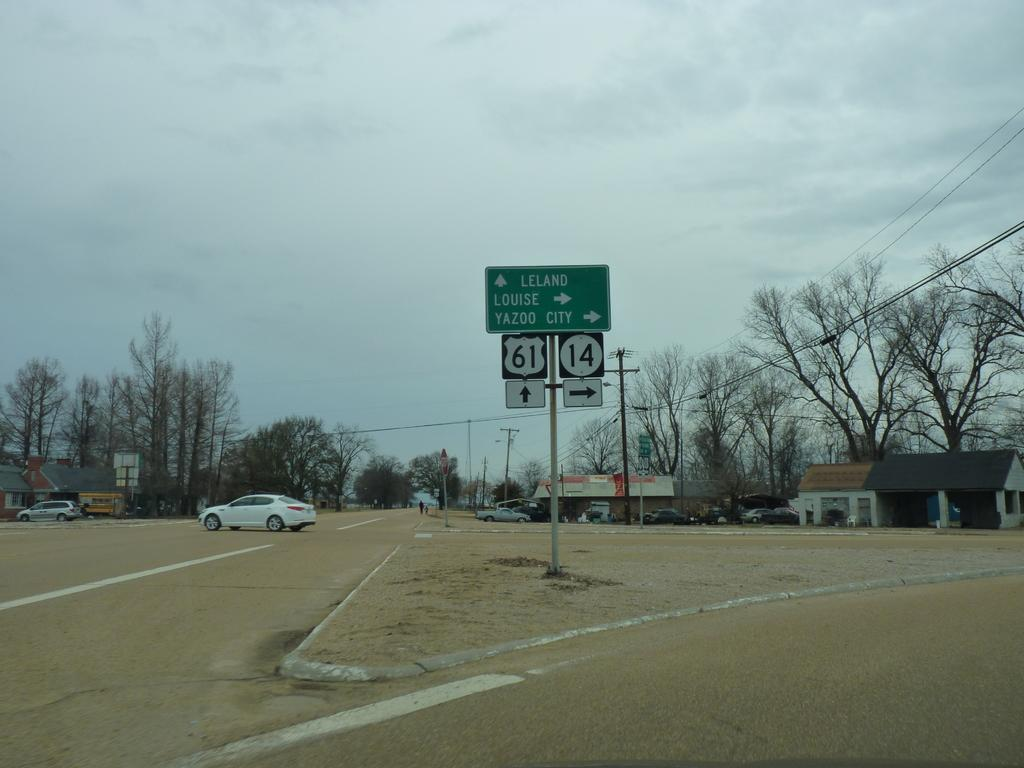<image>
Describe the image concisely. A green sign with the words leland louise yazoo city post in the media of the road. 